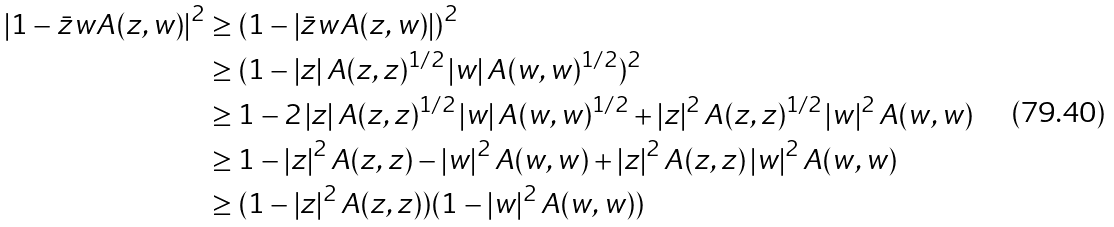Convert formula to latex. <formula><loc_0><loc_0><loc_500><loc_500>\left | 1 - \bar { z } w A ( z , w ) \right | ^ { 2 } & \geq \left ( 1 - \left | \bar { z } w A ( z , w ) \right | \right ) ^ { 2 } \\ & \geq ( 1 - \left | z \right | A ( z , z ) ^ { 1 / 2 } \left | w \right | A ( w , w ) ^ { 1 / 2 } ) ^ { 2 } \\ & \geq 1 - 2 \left | z \right | A ( z , z ) ^ { 1 / 2 } \left | w \right | A ( w , w ) ^ { 1 / 2 } + \left | z \right | ^ { 2 } A ( z , z ) ^ { 1 / 2 } \left | w \right | ^ { 2 } A ( w , w ) \\ & \geq 1 - \left | z \right | ^ { 2 } A ( z , z ) - \left | w \right | ^ { 2 } A ( w , w ) + \left | z \right | ^ { 2 } A ( z , z ) \left | w \right | ^ { 2 } A ( w , w ) \\ & \geq ( 1 - \left | z \right | ^ { 2 } A ( z , z ) ) ( 1 - \left | w \right | ^ { 2 } A ( w , w ) )</formula> 